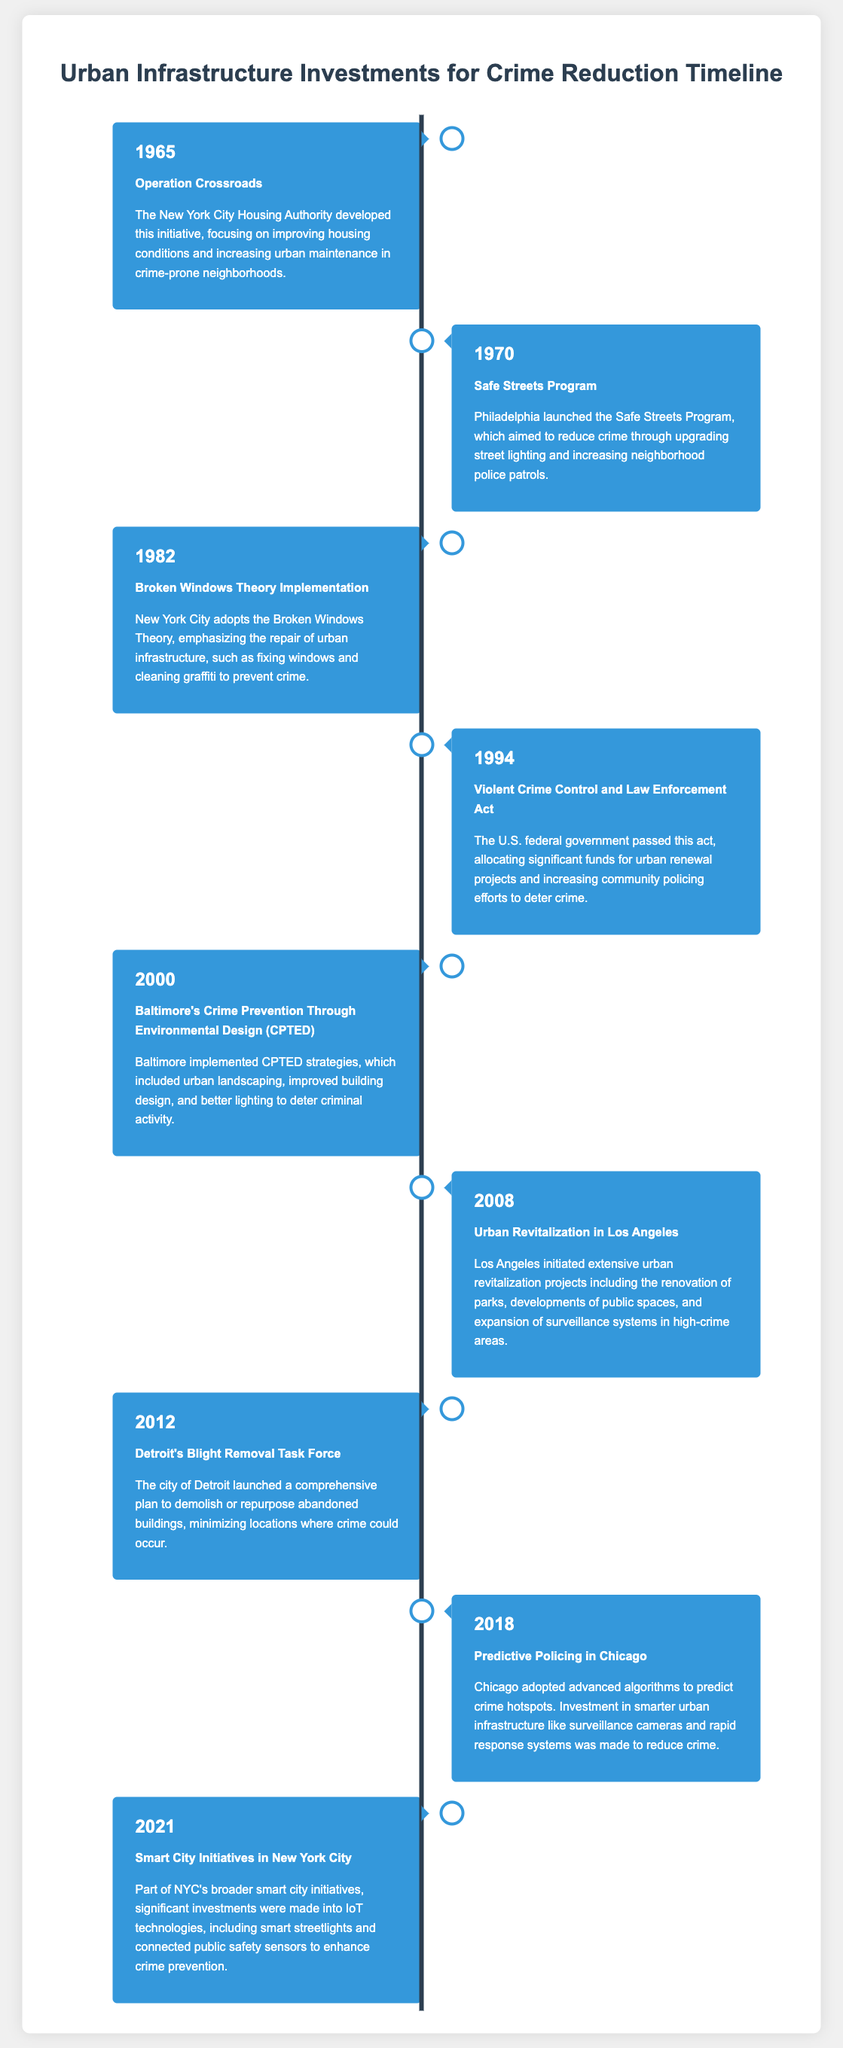What year was the Safe Streets Program launched? The Safe Streets Program was launched in Philadelphia in 1970.
Answer: 1970 What theory was implemented in New York City in 1982? The Broken Windows Theory was adopted in New York City in 1982 to prevent crime.
Answer: Broken Windows Theory Which initiative did Baltimore launch in 2000? Baltimore implemented Crime Prevention Through Environmental Design (CPTED) strategies to deter criminal activity in 2000.
Answer: CPTED How much funding was allocated by the Violent Crime Control and Law Enforcement Act in 1994? The act allocated significant funds for urban renewal projects and community policing efforts.
Answer: Significant funds What urban strategy did Detroit's Blight Removal Task Force focus on in 2012? The focus was on demolishing or repurposing abandoned buildings to minimize crime locations.
Answer: Demolishing or repurposing abandoned buildings Which city adopted predictive policing in 2018? Chicago adopted advanced algorithms for predictive policing in 2018.
Answer: Chicago What investment did New York City make as part of its smart city initiatives in 2021? Significant investments were made into IoT technologies, such as smart streetlights and public safety sensors.
Answer: IoT technologies What type of lighting was emphasized in Philadelphia's Safe Streets Program? The program aimed to upgrade street lighting as part of its crime reduction strategy.
Answer: Street lighting 